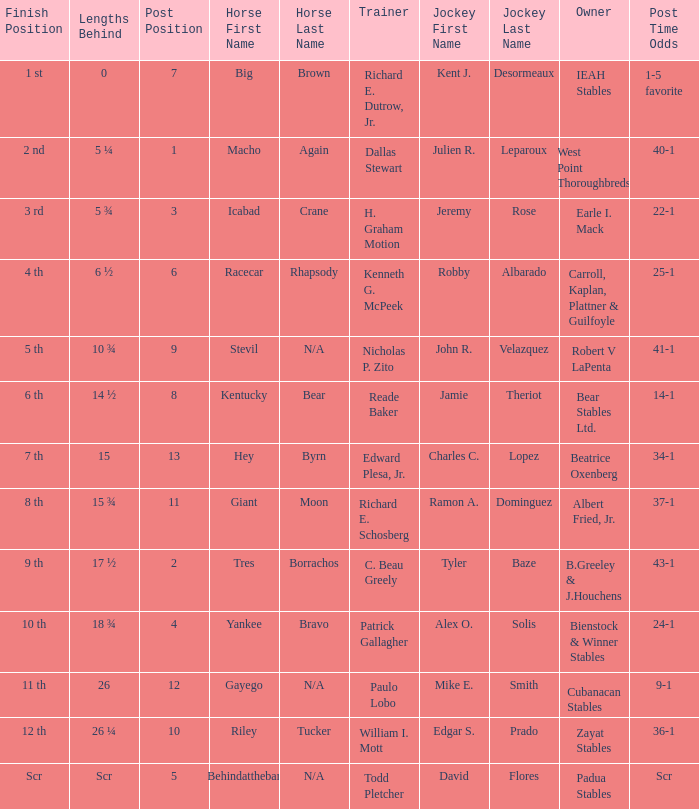What's the lengths behind of Jockey Ramon A. Dominguez? 15 ¾. Could you parse the entire table as a dict? {'header': ['Finish Position', 'Lengths Behind', 'Post Position', 'Horse First Name', 'Horse Last Name', 'Trainer', 'Jockey First Name', 'Jockey Last Name', 'Owner', 'Post Time Odds'], 'rows': [['1 st', '0', '7', 'Big', 'Brown', 'Richard E. Dutrow, Jr.', 'Kent J.', 'Desormeaux', 'IEAH Stables', '1-5 favorite'], ['2 nd', '5 ¼', '1', 'Macho', 'Again', 'Dallas Stewart', 'Julien R.', 'Leparoux', 'West Point Thoroughbreds', '40-1'], ['3 rd', '5 ¾', '3', 'Icabad', 'Crane', 'H. Graham Motion', 'Jeremy', 'Rose', 'Earle I. Mack', '22-1'], ['4 th', '6 ½', '6', 'Racecar', 'Rhapsody', 'Kenneth G. McPeek', 'Robby', 'Albarado', 'Carroll, Kaplan, Plattner & Guilfoyle', '25-1'], ['5 th', '10 ¾', '9', 'Stevil', 'N/A', 'Nicholas P. Zito', 'John R.', 'Velazquez', 'Robert V LaPenta', '41-1'], ['6 th', '14 ½', '8', 'Kentucky', 'Bear', 'Reade Baker', 'Jamie', 'Theriot', 'Bear Stables Ltd.', '14-1'], ['7 th', '15', '13', 'Hey', 'Byrn', 'Edward Plesa, Jr.', 'Charles C.', 'Lopez', 'Beatrice Oxenberg', '34-1'], ['8 th', '15 ¾', '11', 'Giant', 'Moon', 'Richard E. Schosberg', 'Ramon A.', 'Dominguez', 'Albert Fried, Jr.', '37-1'], ['9 th', '17 ½', '2', 'Tres', 'Borrachos', 'C. Beau Greely', 'Tyler', 'Baze', 'B.Greeley & J.Houchens', '43-1'], ['10 th', '18 ¾', '4', 'Yankee', 'Bravo', 'Patrick Gallagher', 'Alex O.', 'Solis', 'Bienstock & Winner Stables', '24-1'], ['11 th', '26', '12', 'Gayego', 'N/A', 'Paulo Lobo', 'Mike E.', 'Smith', 'Cubanacan Stables', '9-1'], ['12 th', '26 ¼', '10', 'Riley', 'Tucker', 'William I. Mott', 'Edgar S.', 'Prado', 'Zayat Stables', '36-1'], ['Scr', 'Scr', '5', 'Behindatthebar', 'N/A', 'Todd Pletcher', 'David', 'Flores', 'Padua Stables', 'Scr']]} 